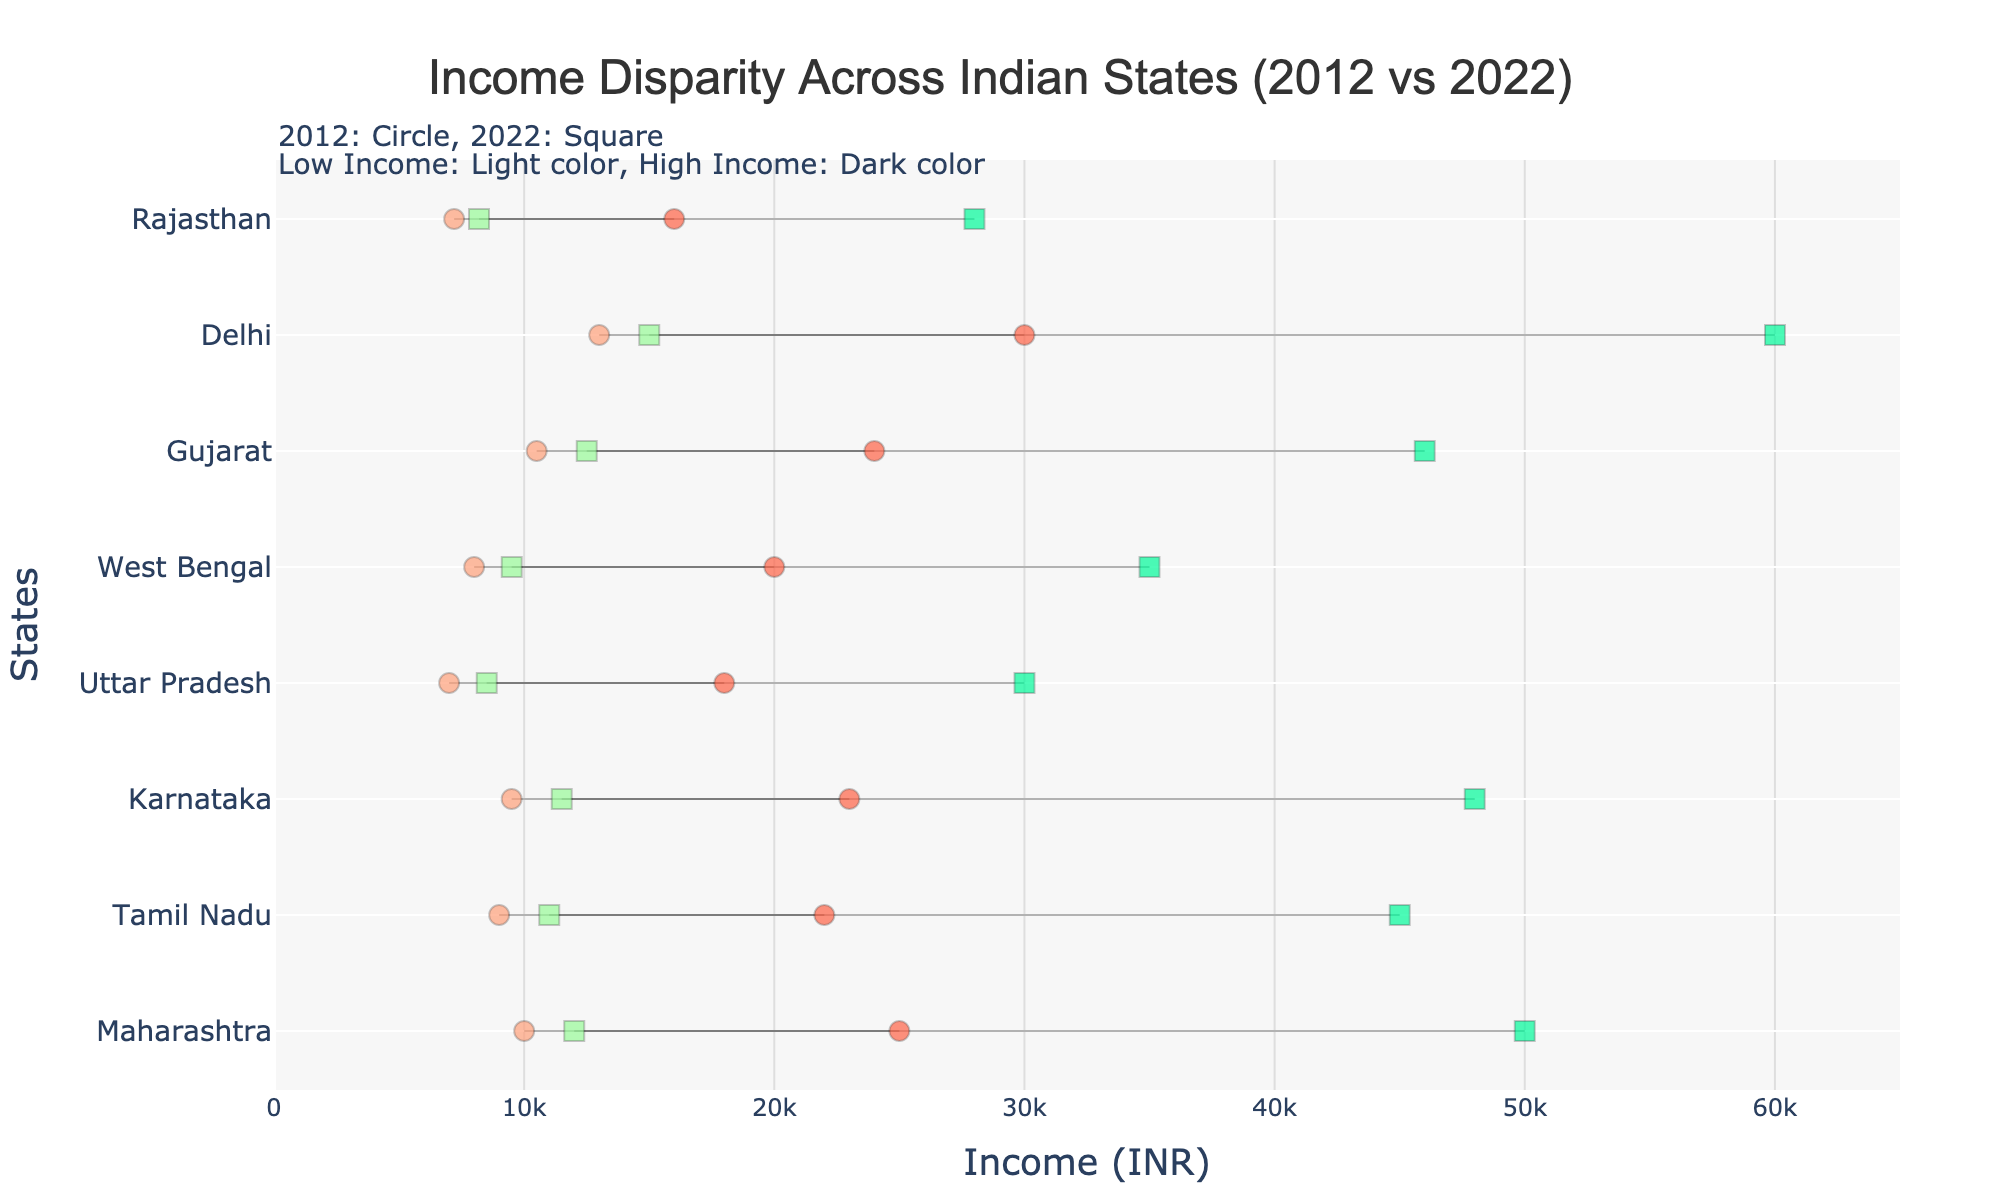what is the title of the plot? The title of a plot shows the main focus or the overall summary of what the data in the chart is about. In this case, it highlights the main content. Look at the top center of the plot to find the title.
Answer: Income Disparity Across Indian States (2012 vs 2022) What income range is represented by the square marker for Karnataka? Square markers indicate the income range for the year 2022. Look for the square markers associated with Karnataka and note their corresponding income values on the x-axis.
Answer: 11500 to 48000 INR How has the high income in Delhi changed from 2012 to 2022? To determine the change, compare the high-income value for Delhi in 2012 (circle markers) and in 2022 (square markers). Note down the two values and subtract the 2012 value from the 2022 value to find the difference.
Answer: Increased by 30000 INR Which state had the lowest high income in 2012? Identify the high-income values (darker color circle markers) for all states in 2012. Compare these values to find the lowest one.
Answer: Rajasthan What is the overall income range difference for Tamil Nadu between 2012 and 2022? First, find Tamil Nadu's income ranges for 2012 and 2022 using the respective markers. Calculate the income range for both years (high income - low income). Then, compute their difference.
Answer: Increased by 5000 INR Are there any states where both low and high incomes decreased from 2012 to 2022? Check each state individually. Compare the low and high incomes of 2012 (circle markers) with those of 2022 (square markers). Identify if there’s any state where both of these values decreased.
Answer: None Which state had the highest increase in high income over the decade? Examine the high-income values for all states in 2012 (circle markers) and 2022 (square markers). Calculate the increase for each state by subtracting 2012 values from 2022 values and find the maximum increase.
Answer: Delhi What is the income disparity range for Uttar Pradesh in 2022? Look at Uttar Pradesh’s income markers for 2022 (square markers). Subtract the low income from the high income to determine the disparity range.
Answer: 21500 INR 